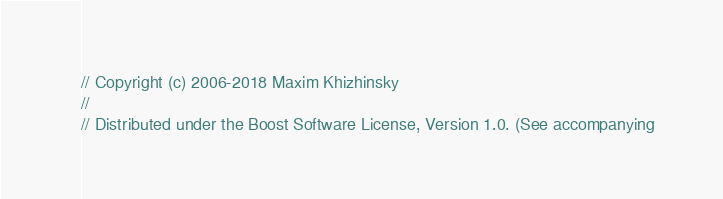Convert code to text. <code><loc_0><loc_0><loc_500><loc_500><_C_>// Copyright (c) 2006-2018 Maxim Khizhinsky
//
// Distributed under the Boost Software License, Version 1.0. (See accompanying</code> 